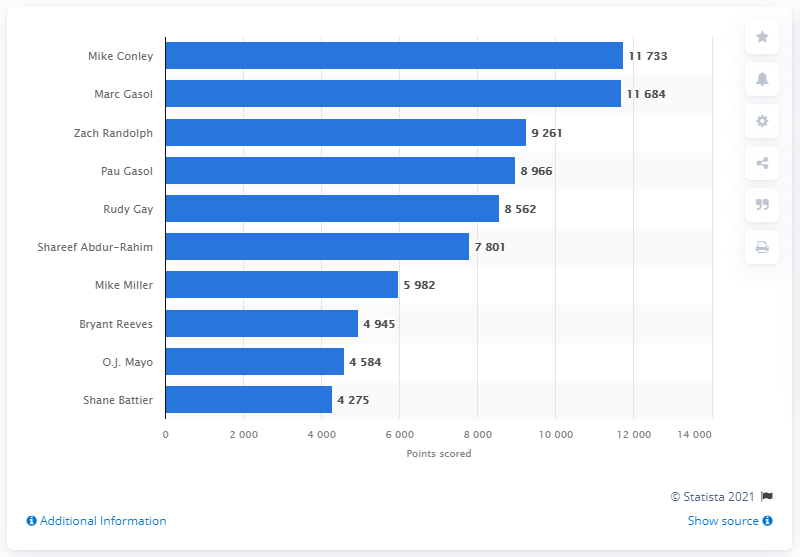List a handful of essential elements in this visual. Mike Conley is the career points leader of the Memphis Grizzlies. 